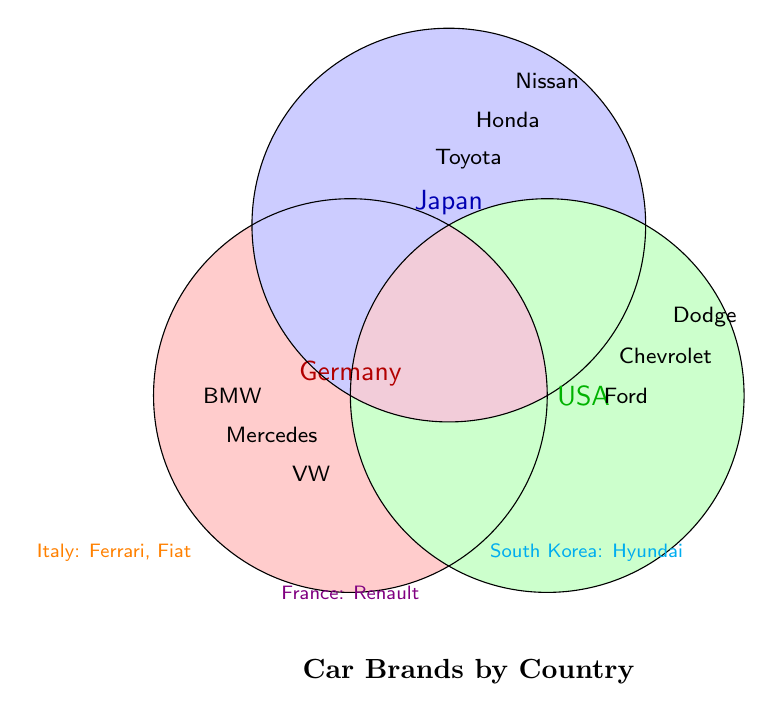What is the title of the Venn Diagram? The title is found at the bottom center of the diagram in bold text. It reads "Car Brands by Country".
Answer: Car Brands by Country Which country is represented by the red circle? The red circle has the label "Germany" placed above it in the figure.
Answer: Germany How many car brands are listed in the USA circle? The USA circle is on the right side, colored green, containing "Ford", "Chevrolet", and "Dodge" which totals 3 brands.
Answer: 3 Which car brand from Italy is shown in the figure? Italy is listed below the main circles with the text "Italy: Ferrari, Fiat" in orange.
Answer: Ferrari, Fiat Where is France's car brand location in the figure? France's car brand, Renault, is written below the main circles, slightly to the right.
Answer: Below the main circles to the right How many countries are represented outside the main Venn Diagram circles? Outside the main Venn Diagram circles, Italy, France, and South Korea are mentioned, making 3 countries.
Answer: 3 Which car brands are in the Japan circle? The Japan circle, labeled with blue and located at the top, contains "Toyota", "Honda", and "Nissan".
Answer: Toyota, Honda, Nissan What color is the section where Germany and Japan overlap? The overlapping regions are shaded with purple, which is created by combining red from Germany and blue from Japan.
Answer: Purple Identify the car brand of South Korea in the diagram. South Korea is labeled below the main diagram circles with the text "South Korea: Hyundai" in cyan color.
Answer: Hyundai What brand is listed in Germany but not in the USA or Japan? The Germany circle, colored red, contains "BMW", "Mercedes", and "VW" without having any overlapping regions with other circles.
Answer: BMW, Mercedes, VW 